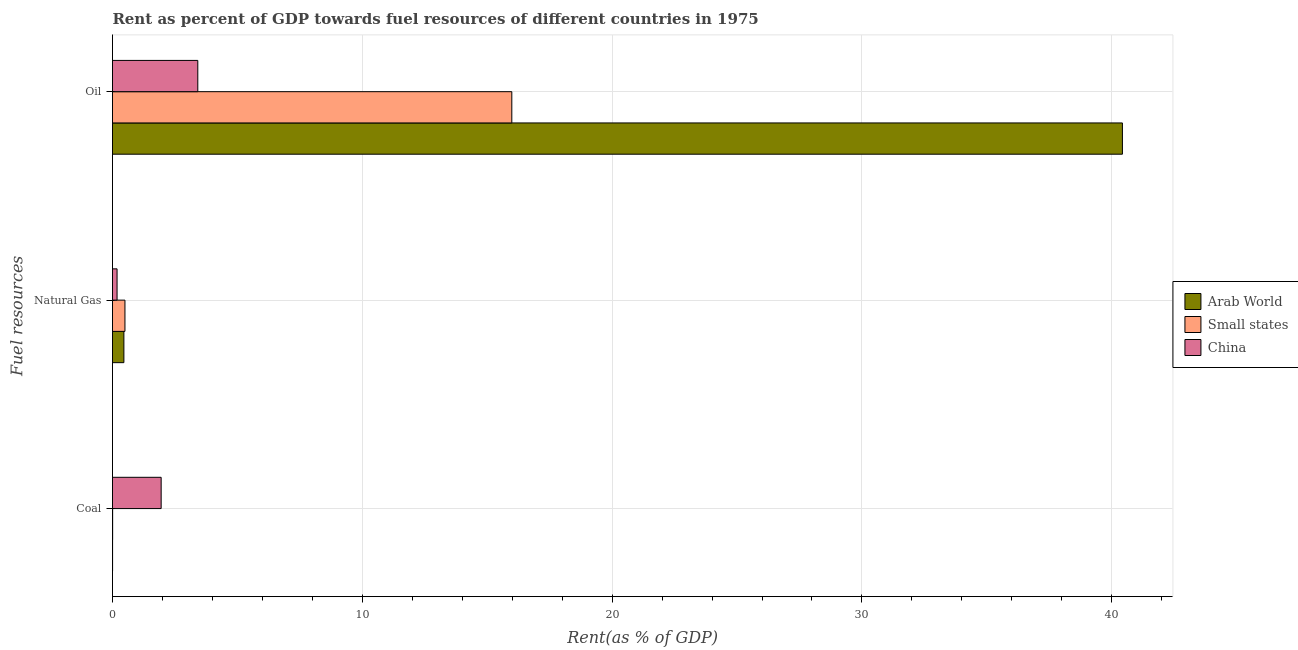How many different coloured bars are there?
Your answer should be very brief. 3. How many groups of bars are there?
Provide a succinct answer. 3. How many bars are there on the 3rd tick from the bottom?
Your answer should be very brief. 3. What is the label of the 3rd group of bars from the top?
Your response must be concise. Coal. What is the rent towards oil in China?
Offer a very short reply. 3.41. Across all countries, what is the maximum rent towards oil?
Your answer should be compact. 40.43. Across all countries, what is the minimum rent towards natural gas?
Your response must be concise. 0.18. In which country was the rent towards coal minimum?
Your answer should be compact. Arab World. What is the total rent towards natural gas in the graph?
Provide a succinct answer. 1.14. What is the difference between the rent towards natural gas in Arab World and that in China?
Make the answer very short. 0.27. What is the difference between the rent towards natural gas in Arab World and the rent towards oil in China?
Provide a short and direct response. -2.96. What is the average rent towards oil per country?
Make the answer very short. 19.94. What is the difference between the rent towards oil and rent towards natural gas in Arab World?
Ensure brevity in your answer.  39.97. In how many countries, is the rent towards coal greater than 2 %?
Provide a succinct answer. 0. What is the ratio of the rent towards oil in Arab World to that in Small states?
Keep it short and to the point. 2.53. Is the difference between the rent towards oil in China and Arab World greater than the difference between the rent towards coal in China and Arab World?
Provide a succinct answer. No. What is the difference between the highest and the second highest rent towards oil?
Ensure brevity in your answer.  24.44. What is the difference between the highest and the lowest rent towards coal?
Provide a succinct answer. 1.94. Is the sum of the rent towards natural gas in Small states and Arab World greater than the maximum rent towards oil across all countries?
Offer a very short reply. No. What does the 3rd bar from the top in Coal represents?
Offer a very short reply. Arab World. What does the 2nd bar from the bottom in Coal represents?
Your response must be concise. Small states. Is it the case that in every country, the sum of the rent towards coal and rent towards natural gas is greater than the rent towards oil?
Offer a terse response. No. What is the difference between two consecutive major ticks on the X-axis?
Keep it short and to the point. 10. Where does the legend appear in the graph?
Your response must be concise. Center right. How are the legend labels stacked?
Ensure brevity in your answer.  Vertical. What is the title of the graph?
Your answer should be compact. Rent as percent of GDP towards fuel resources of different countries in 1975. Does "Turkmenistan" appear as one of the legend labels in the graph?
Provide a succinct answer. No. What is the label or title of the X-axis?
Offer a terse response. Rent(as % of GDP). What is the label or title of the Y-axis?
Keep it short and to the point. Fuel resources. What is the Rent(as % of GDP) in Arab World in Coal?
Keep it short and to the point. 0. What is the Rent(as % of GDP) in Small states in Coal?
Your response must be concise. 0.01. What is the Rent(as % of GDP) of China in Coal?
Provide a short and direct response. 1.95. What is the Rent(as % of GDP) of Arab World in Natural Gas?
Give a very brief answer. 0.46. What is the Rent(as % of GDP) in Small states in Natural Gas?
Ensure brevity in your answer.  0.5. What is the Rent(as % of GDP) in China in Natural Gas?
Offer a terse response. 0.18. What is the Rent(as % of GDP) in Arab World in Oil?
Offer a very short reply. 40.43. What is the Rent(as % of GDP) of Small states in Oil?
Offer a terse response. 15.99. What is the Rent(as % of GDP) of China in Oil?
Offer a terse response. 3.41. Across all Fuel resources, what is the maximum Rent(as % of GDP) in Arab World?
Provide a succinct answer. 40.43. Across all Fuel resources, what is the maximum Rent(as % of GDP) of Small states?
Give a very brief answer. 15.99. Across all Fuel resources, what is the maximum Rent(as % of GDP) in China?
Your answer should be very brief. 3.41. Across all Fuel resources, what is the minimum Rent(as % of GDP) of Arab World?
Give a very brief answer. 0. Across all Fuel resources, what is the minimum Rent(as % of GDP) of Small states?
Offer a very short reply. 0.01. Across all Fuel resources, what is the minimum Rent(as % of GDP) in China?
Offer a very short reply. 0.18. What is the total Rent(as % of GDP) of Arab World in the graph?
Your response must be concise. 40.89. What is the total Rent(as % of GDP) of Small states in the graph?
Your answer should be very brief. 16.49. What is the total Rent(as % of GDP) of China in the graph?
Offer a very short reply. 5.54. What is the difference between the Rent(as % of GDP) of Arab World in Coal and that in Natural Gas?
Ensure brevity in your answer.  -0.45. What is the difference between the Rent(as % of GDP) of Small states in Coal and that in Natural Gas?
Your answer should be very brief. -0.49. What is the difference between the Rent(as % of GDP) in China in Coal and that in Natural Gas?
Provide a succinct answer. 1.76. What is the difference between the Rent(as % of GDP) in Arab World in Coal and that in Oil?
Give a very brief answer. -40.42. What is the difference between the Rent(as % of GDP) in Small states in Coal and that in Oil?
Make the answer very short. -15.98. What is the difference between the Rent(as % of GDP) of China in Coal and that in Oil?
Make the answer very short. -1.47. What is the difference between the Rent(as % of GDP) of Arab World in Natural Gas and that in Oil?
Ensure brevity in your answer.  -39.97. What is the difference between the Rent(as % of GDP) in Small states in Natural Gas and that in Oil?
Ensure brevity in your answer.  -15.49. What is the difference between the Rent(as % of GDP) in China in Natural Gas and that in Oil?
Your answer should be very brief. -3.23. What is the difference between the Rent(as % of GDP) in Arab World in Coal and the Rent(as % of GDP) in Small states in Natural Gas?
Your answer should be very brief. -0.5. What is the difference between the Rent(as % of GDP) in Arab World in Coal and the Rent(as % of GDP) in China in Natural Gas?
Make the answer very short. -0.18. What is the difference between the Rent(as % of GDP) of Small states in Coal and the Rent(as % of GDP) of China in Natural Gas?
Your response must be concise. -0.18. What is the difference between the Rent(as % of GDP) in Arab World in Coal and the Rent(as % of GDP) in Small states in Oil?
Provide a succinct answer. -15.98. What is the difference between the Rent(as % of GDP) of Arab World in Coal and the Rent(as % of GDP) of China in Oil?
Provide a short and direct response. -3.41. What is the difference between the Rent(as % of GDP) of Small states in Coal and the Rent(as % of GDP) of China in Oil?
Give a very brief answer. -3.41. What is the difference between the Rent(as % of GDP) in Arab World in Natural Gas and the Rent(as % of GDP) in Small states in Oil?
Your answer should be very brief. -15.53. What is the difference between the Rent(as % of GDP) of Arab World in Natural Gas and the Rent(as % of GDP) of China in Oil?
Offer a terse response. -2.96. What is the difference between the Rent(as % of GDP) of Small states in Natural Gas and the Rent(as % of GDP) of China in Oil?
Your answer should be compact. -2.92. What is the average Rent(as % of GDP) of Arab World per Fuel resources?
Ensure brevity in your answer.  13.63. What is the average Rent(as % of GDP) of Small states per Fuel resources?
Provide a short and direct response. 5.5. What is the average Rent(as % of GDP) in China per Fuel resources?
Your response must be concise. 1.85. What is the difference between the Rent(as % of GDP) of Arab World and Rent(as % of GDP) of Small states in Coal?
Offer a very short reply. -0. What is the difference between the Rent(as % of GDP) of Arab World and Rent(as % of GDP) of China in Coal?
Your answer should be compact. -1.94. What is the difference between the Rent(as % of GDP) in Small states and Rent(as % of GDP) in China in Coal?
Keep it short and to the point. -1.94. What is the difference between the Rent(as % of GDP) of Arab World and Rent(as % of GDP) of Small states in Natural Gas?
Offer a very short reply. -0.04. What is the difference between the Rent(as % of GDP) in Arab World and Rent(as % of GDP) in China in Natural Gas?
Provide a short and direct response. 0.27. What is the difference between the Rent(as % of GDP) in Small states and Rent(as % of GDP) in China in Natural Gas?
Your response must be concise. 0.32. What is the difference between the Rent(as % of GDP) in Arab World and Rent(as % of GDP) in Small states in Oil?
Your response must be concise. 24.44. What is the difference between the Rent(as % of GDP) of Arab World and Rent(as % of GDP) of China in Oil?
Ensure brevity in your answer.  37.01. What is the difference between the Rent(as % of GDP) in Small states and Rent(as % of GDP) in China in Oil?
Offer a very short reply. 12.57. What is the ratio of the Rent(as % of GDP) of Arab World in Coal to that in Natural Gas?
Your response must be concise. 0.01. What is the ratio of the Rent(as % of GDP) in Small states in Coal to that in Natural Gas?
Offer a terse response. 0.01. What is the ratio of the Rent(as % of GDP) in China in Coal to that in Natural Gas?
Your answer should be very brief. 10.67. What is the ratio of the Rent(as % of GDP) in China in Coal to that in Oil?
Your answer should be very brief. 0.57. What is the ratio of the Rent(as % of GDP) of Arab World in Natural Gas to that in Oil?
Your answer should be very brief. 0.01. What is the ratio of the Rent(as % of GDP) of Small states in Natural Gas to that in Oil?
Ensure brevity in your answer.  0.03. What is the ratio of the Rent(as % of GDP) of China in Natural Gas to that in Oil?
Give a very brief answer. 0.05. What is the difference between the highest and the second highest Rent(as % of GDP) in Arab World?
Keep it short and to the point. 39.97. What is the difference between the highest and the second highest Rent(as % of GDP) in Small states?
Your answer should be compact. 15.49. What is the difference between the highest and the second highest Rent(as % of GDP) in China?
Make the answer very short. 1.47. What is the difference between the highest and the lowest Rent(as % of GDP) of Arab World?
Ensure brevity in your answer.  40.42. What is the difference between the highest and the lowest Rent(as % of GDP) of Small states?
Your answer should be compact. 15.98. What is the difference between the highest and the lowest Rent(as % of GDP) in China?
Give a very brief answer. 3.23. 